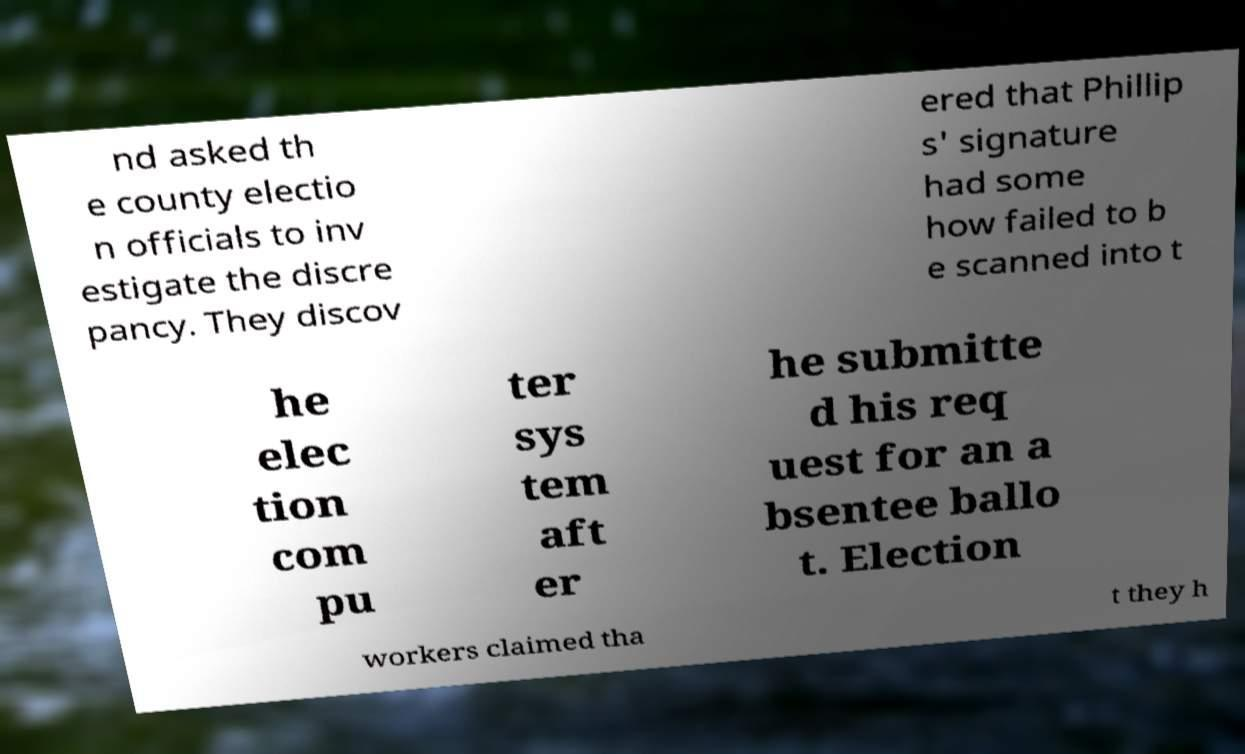Please read and relay the text visible in this image. What does it say? nd asked th e county electio n officials to inv estigate the discre pancy. They discov ered that Phillip s' signature had some how failed to b e scanned into t he elec tion com pu ter sys tem aft er he submitte d his req uest for an a bsentee ballo t. Election workers claimed tha t they h 